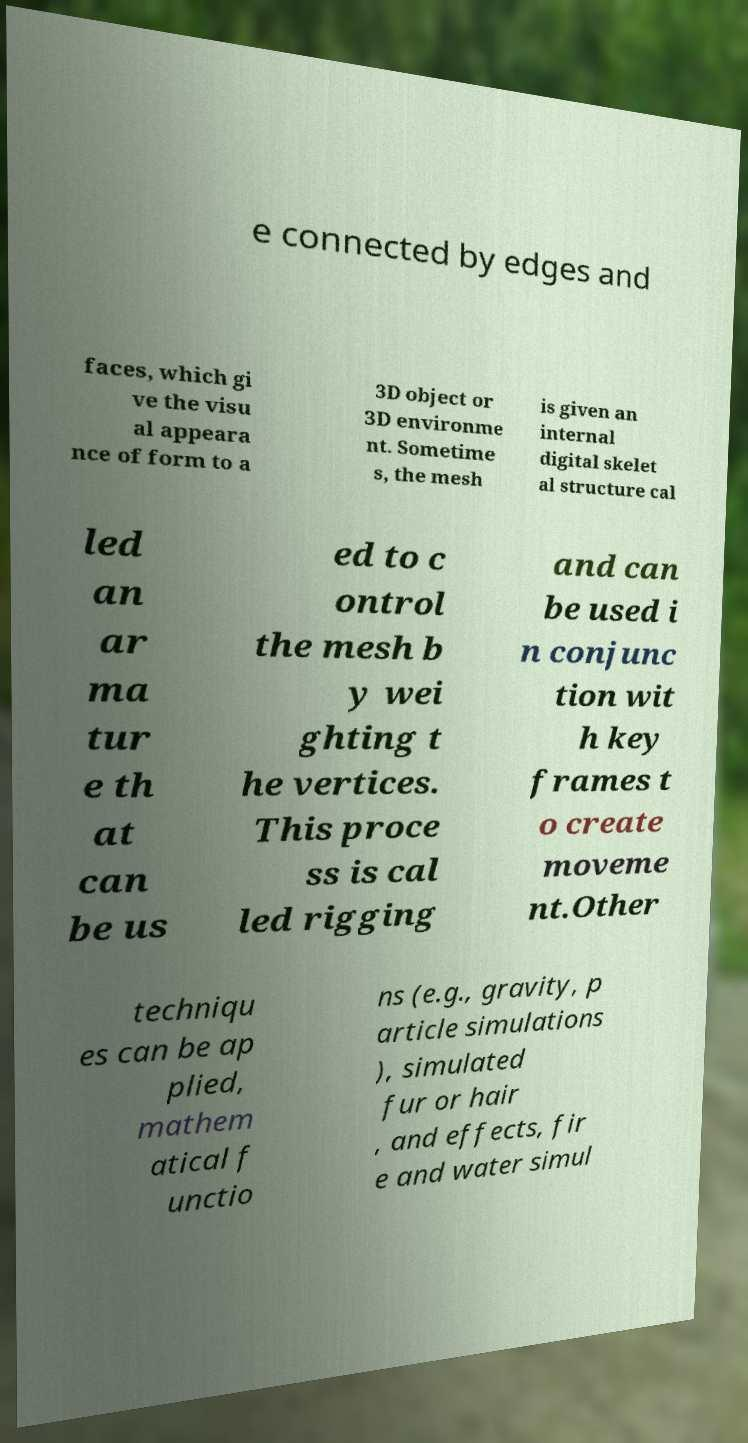What messages or text are displayed in this image? I need them in a readable, typed format. e connected by edges and faces, which gi ve the visu al appeara nce of form to a 3D object or 3D environme nt. Sometime s, the mesh is given an internal digital skelet al structure cal led an ar ma tur e th at can be us ed to c ontrol the mesh b y wei ghting t he vertices. This proce ss is cal led rigging and can be used i n conjunc tion wit h key frames t o create moveme nt.Other techniqu es can be ap plied, mathem atical f unctio ns (e.g., gravity, p article simulations ), simulated fur or hair , and effects, fir e and water simul 